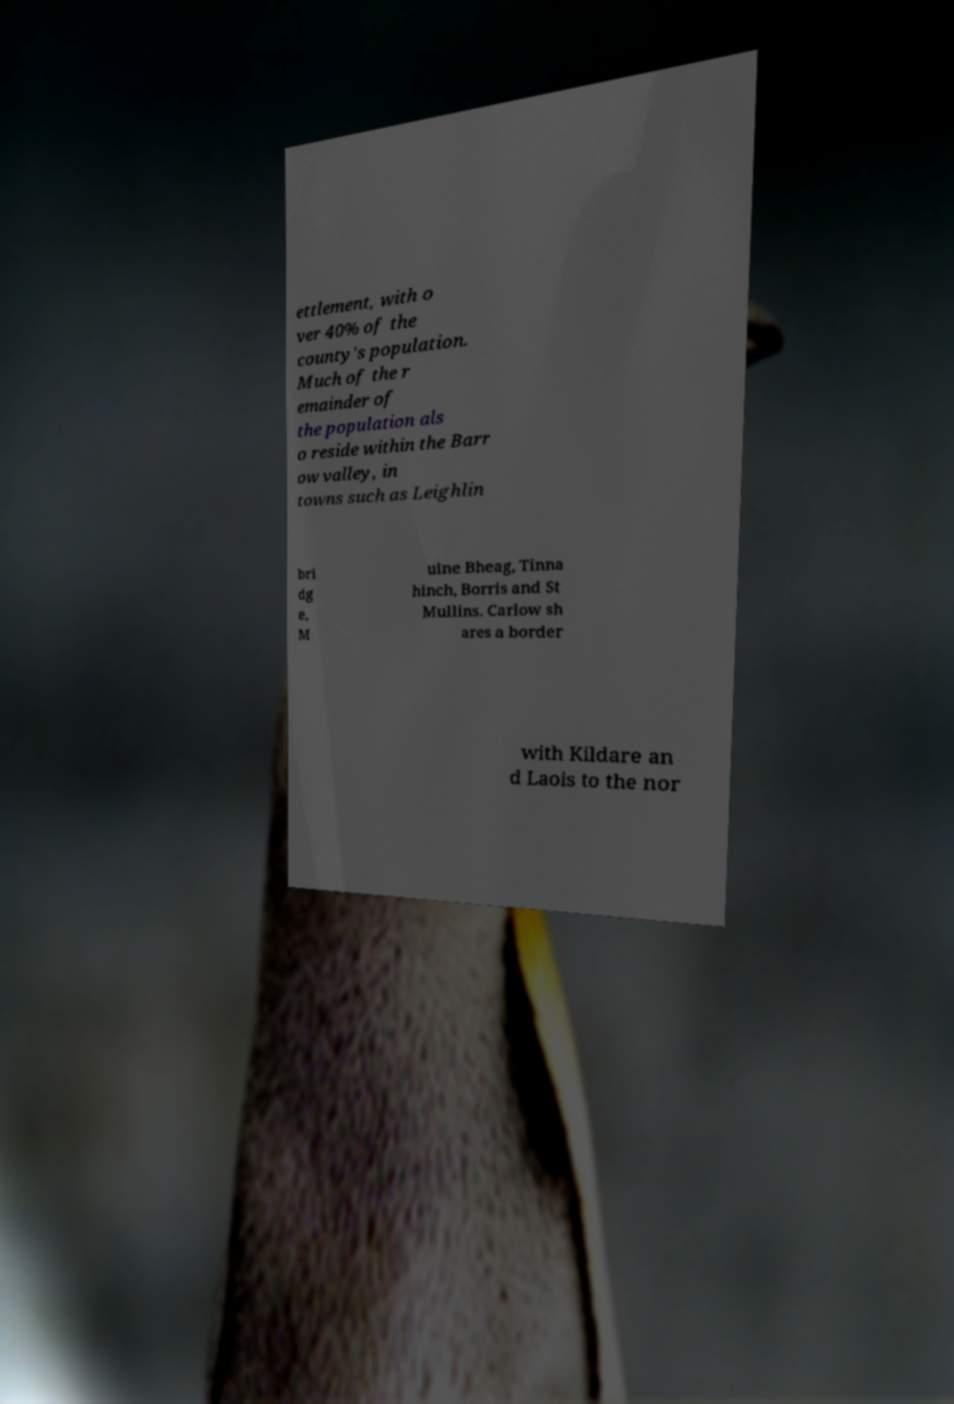Can you read and provide the text displayed in the image?This photo seems to have some interesting text. Can you extract and type it out for me? ettlement, with o ver 40% of the county's population. Much of the r emainder of the population als o reside within the Barr ow valley, in towns such as Leighlin bri dg e, M uine Bheag, Tinna hinch, Borris and St Mullins. Carlow sh ares a border with Kildare an d Laois to the nor 